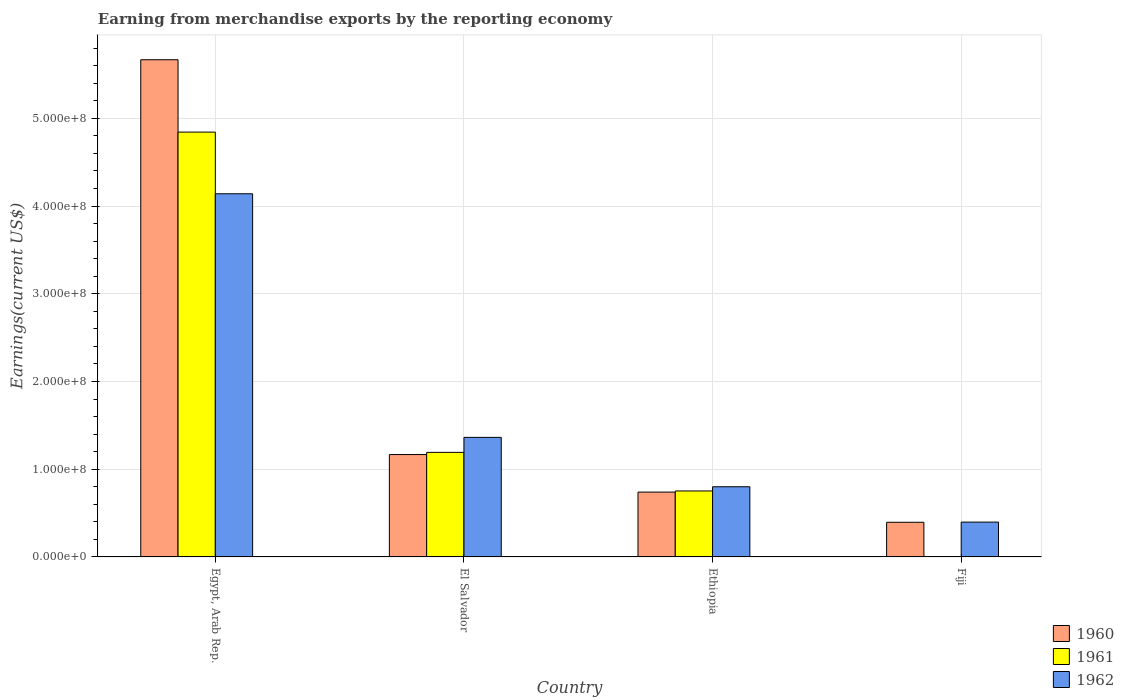Are the number of bars per tick equal to the number of legend labels?
Offer a very short reply. Yes. How many bars are there on the 1st tick from the left?
Provide a short and direct response. 3. How many bars are there on the 3rd tick from the right?
Make the answer very short. 3. What is the label of the 1st group of bars from the left?
Make the answer very short. Egypt, Arab Rep. In how many cases, is the number of bars for a given country not equal to the number of legend labels?
Make the answer very short. 0. What is the amount earned from merchandise exports in 1962 in Ethiopia?
Your answer should be very brief. 8.00e+07. Across all countries, what is the maximum amount earned from merchandise exports in 1961?
Offer a terse response. 4.84e+08. Across all countries, what is the minimum amount earned from merchandise exports in 1960?
Ensure brevity in your answer.  3.95e+07. In which country was the amount earned from merchandise exports in 1962 maximum?
Make the answer very short. Egypt, Arab Rep. In which country was the amount earned from merchandise exports in 1962 minimum?
Give a very brief answer. Fiji. What is the total amount earned from merchandise exports in 1961 in the graph?
Make the answer very short. 6.79e+08. What is the difference between the amount earned from merchandise exports in 1960 in Egypt, Arab Rep. and that in Ethiopia?
Your answer should be very brief. 4.93e+08. What is the difference between the amount earned from merchandise exports in 1960 in El Salvador and the amount earned from merchandise exports in 1962 in Ethiopia?
Provide a succinct answer. 3.67e+07. What is the average amount earned from merchandise exports in 1962 per country?
Provide a succinct answer. 1.68e+08. What is the difference between the amount earned from merchandise exports of/in 1960 and amount earned from merchandise exports of/in 1962 in Ethiopia?
Your answer should be very brief. -6.10e+06. In how many countries, is the amount earned from merchandise exports in 1962 greater than 560000000 US$?
Make the answer very short. 0. What is the ratio of the amount earned from merchandise exports in 1960 in Egypt, Arab Rep. to that in Ethiopia?
Ensure brevity in your answer.  7.67. What is the difference between the highest and the second highest amount earned from merchandise exports in 1960?
Provide a succinct answer. 4.50e+08. What is the difference between the highest and the lowest amount earned from merchandise exports in 1962?
Give a very brief answer. 3.74e+08. In how many countries, is the amount earned from merchandise exports in 1960 greater than the average amount earned from merchandise exports in 1960 taken over all countries?
Your answer should be very brief. 1. What does the 3rd bar from the left in Ethiopia represents?
Ensure brevity in your answer.  1962. How many bars are there?
Give a very brief answer. 12. How many countries are there in the graph?
Keep it short and to the point. 4. Does the graph contain any zero values?
Your answer should be compact. No. Does the graph contain grids?
Give a very brief answer. Yes. How are the legend labels stacked?
Offer a terse response. Vertical. What is the title of the graph?
Give a very brief answer. Earning from merchandise exports by the reporting economy. Does "1984" appear as one of the legend labels in the graph?
Offer a terse response. No. What is the label or title of the X-axis?
Give a very brief answer. Country. What is the label or title of the Y-axis?
Give a very brief answer. Earnings(current US$). What is the Earnings(current US$) in 1960 in Egypt, Arab Rep.?
Ensure brevity in your answer.  5.67e+08. What is the Earnings(current US$) in 1961 in Egypt, Arab Rep.?
Offer a very short reply. 4.84e+08. What is the Earnings(current US$) in 1962 in Egypt, Arab Rep.?
Make the answer very short. 4.14e+08. What is the Earnings(current US$) of 1960 in El Salvador?
Offer a very short reply. 1.17e+08. What is the Earnings(current US$) in 1961 in El Salvador?
Your answer should be compact. 1.19e+08. What is the Earnings(current US$) of 1962 in El Salvador?
Provide a short and direct response. 1.36e+08. What is the Earnings(current US$) in 1960 in Ethiopia?
Your answer should be compact. 7.39e+07. What is the Earnings(current US$) in 1961 in Ethiopia?
Your answer should be very brief. 7.52e+07. What is the Earnings(current US$) of 1962 in Ethiopia?
Your answer should be very brief. 8.00e+07. What is the Earnings(current US$) of 1960 in Fiji?
Provide a short and direct response. 3.95e+07. What is the Earnings(current US$) in 1962 in Fiji?
Keep it short and to the point. 3.97e+07. Across all countries, what is the maximum Earnings(current US$) of 1960?
Provide a succinct answer. 5.67e+08. Across all countries, what is the maximum Earnings(current US$) in 1961?
Provide a short and direct response. 4.84e+08. Across all countries, what is the maximum Earnings(current US$) in 1962?
Your answer should be compact. 4.14e+08. Across all countries, what is the minimum Earnings(current US$) of 1960?
Keep it short and to the point. 3.95e+07. Across all countries, what is the minimum Earnings(current US$) of 1962?
Offer a very short reply. 3.97e+07. What is the total Earnings(current US$) in 1960 in the graph?
Provide a succinct answer. 7.97e+08. What is the total Earnings(current US$) in 1961 in the graph?
Offer a terse response. 6.79e+08. What is the total Earnings(current US$) of 1962 in the graph?
Offer a terse response. 6.70e+08. What is the difference between the Earnings(current US$) in 1960 in Egypt, Arab Rep. and that in El Salvador?
Give a very brief answer. 4.50e+08. What is the difference between the Earnings(current US$) of 1961 in Egypt, Arab Rep. and that in El Salvador?
Offer a terse response. 3.65e+08. What is the difference between the Earnings(current US$) in 1962 in Egypt, Arab Rep. and that in El Salvador?
Ensure brevity in your answer.  2.78e+08. What is the difference between the Earnings(current US$) in 1960 in Egypt, Arab Rep. and that in Ethiopia?
Your response must be concise. 4.93e+08. What is the difference between the Earnings(current US$) in 1961 in Egypt, Arab Rep. and that in Ethiopia?
Your answer should be very brief. 4.09e+08. What is the difference between the Earnings(current US$) in 1962 in Egypt, Arab Rep. and that in Ethiopia?
Provide a succinct answer. 3.34e+08. What is the difference between the Earnings(current US$) of 1960 in Egypt, Arab Rep. and that in Fiji?
Make the answer very short. 5.27e+08. What is the difference between the Earnings(current US$) in 1961 in Egypt, Arab Rep. and that in Fiji?
Your answer should be compact. 4.84e+08. What is the difference between the Earnings(current US$) in 1962 in Egypt, Arab Rep. and that in Fiji?
Ensure brevity in your answer.  3.74e+08. What is the difference between the Earnings(current US$) in 1960 in El Salvador and that in Ethiopia?
Your response must be concise. 4.28e+07. What is the difference between the Earnings(current US$) of 1961 in El Salvador and that in Ethiopia?
Keep it short and to the point. 4.40e+07. What is the difference between the Earnings(current US$) in 1962 in El Salvador and that in Ethiopia?
Offer a terse response. 5.63e+07. What is the difference between the Earnings(current US$) in 1960 in El Salvador and that in Fiji?
Your answer should be very brief. 7.72e+07. What is the difference between the Earnings(current US$) in 1961 in El Salvador and that in Fiji?
Ensure brevity in your answer.  1.19e+08. What is the difference between the Earnings(current US$) of 1962 in El Salvador and that in Fiji?
Provide a short and direct response. 9.66e+07. What is the difference between the Earnings(current US$) of 1960 in Ethiopia and that in Fiji?
Make the answer very short. 3.44e+07. What is the difference between the Earnings(current US$) of 1961 in Ethiopia and that in Fiji?
Your answer should be very brief. 7.50e+07. What is the difference between the Earnings(current US$) of 1962 in Ethiopia and that in Fiji?
Give a very brief answer. 4.03e+07. What is the difference between the Earnings(current US$) of 1960 in Egypt, Arab Rep. and the Earnings(current US$) of 1961 in El Salvador?
Provide a succinct answer. 4.48e+08. What is the difference between the Earnings(current US$) in 1960 in Egypt, Arab Rep. and the Earnings(current US$) in 1962 in El Salvador?
Provide a short and direct response. 4.30e+08. What is the difference between the Earnings(current US$) of 1961 in Egypt, Arab Rep. and the Earnings(current US$) of 1962 in El Salvador?
Your answer should be very brief. 3.48e+08. What is the difference between the Earnings(current US$) in 1960 in Egypt, Arab Rep. and the Earnings(current US$) in 1961 in Ethiopia?
Provide a succinct answer. 4.92e+08. What is the difference between the Earnings(current US$) of 1960 in Egypt, Arab Rep. and the Earnings(current US$) of 1962 in Ethiopia?
Your answer should be very brief. 4.87e+08. What is the difference between the Earnings(current US$) of 1961 in Egypt, Arab Rep. and the Earnings(current US$) of 1962 in Ethiopia?
Your answer should be very brief. 4.04e+08. What is the difference between the Earnings(current US$) in 1960 in Egypt, Arab Rep. and the Earnings(current US$) in 1961 in Fiji?
Provide a short and direct response. 5.67e+08. What is the difference between the Earnings(current US$) of 1960 in Egypt, Arab Rep. and the Earnings(current US$) of 1962 in Fiji?
Make the answer very short. 5.27e+08. What is the difference between the Earnings(current US$) of 1961 in Egypt, Arab Rep. and the Earnings(current US$) of 1962 in Fiji?
Provide a short and direct response. 4.45e+08. What is the difference between the Earnings(current US$) in 1960 in El Salvador and the Earnings(current US$) in 1961 in Ethiopia?
Give a very brief answer. 4.15e+07. What is the difference between the Earnings(current US$) of 1960 in El Salvador and the Earnings(current US$) of 1962 in Ethiopia?
Your answer should be very brief. 3.67e+07. What is the difference between the Earnings(current US$) of 1961 in El Salvador and the Earnings(current US$) of 1962 in Ethiopia?
Ensure brevity in your answer.  3.92e+07. What is the difference between the Earnings(current US$) of 1960 in El Salvador and the Earnings(current US$) of 1961 in Fiji?
Make the answer very short. 1.16e+08. What is the difference between the Earnings(current US$) of 1960 in El Salvador and the Earnings(current US$) of 1962 in Fiji?
Provide a short and direct response. 7.70e+07. What is the difference between the Earnings(current US$) of 1961 in El Salvador and the Earnings(current US$) of 1962 in Fiji?
Your response must be concise. 7.95e+07. What is the difference between the Earnings(current US$) in 1960 in Ethiopia and the Earnings(current US$) in 1961 in Fiji?
Your answer should be very brief. 7.37e+07. What is the difference between the Earnings(current US$) of 1960 in Ethiopia and the Earnings(current US$) of 1962 in Fiji?
Your answer should be compact. 3.42e+07. What is the difference between the Earnings(current US$) in 1961 in Ethiopia and the Earnings(current US$) in 1962 in Fiji?
Your response must be concise. 3.55e+07. What is the average Earnings(current US$) of 1960 per country?
Your answer should be compact. 1.99e+08. What is the average Earnings(current US$) of 1961 per country?
Your response must be concise. 1.70e+08. What is the average Earnings(current US$) of 1962 per country?
Offer a terse response. 1.68e+08. What is the difference between the Earnings(current US$) of 1960 and Earnings(current US$) of 1961 in Egypt, Arab Rep.?
Your response must be concise. 8.25e+07. What is the difference between the Earnings(current US$) of 1960 and Earnings(current US$) of 1962 in Egypt, Arab Rep.?
Make the answer very short. 1.53e+08. What is the difference between the Earnings(current US$) of 1961 and Earnings(current US$) of 1962 in Egypt, Arab Rep.?
Give a very brief answer. 7.03e+07. What is the difference between the Earnings(current US$) of 1960 and Earnings(current US$) of 1961 in El Salvador?
Offer a very short reply. -2.50e+06. What is the difference between the Earnings(current US$) in 1960 and Earnings(current US$) in 1962 in El Salvador?
Provide a succinct answer. -1.96e+07. What is the difference between the Earnings(current US$) in 1961 and Earnings(current US$) in 1962 in El Salvador?
Give a very brief answer. -1.71e+07. What is the difference between the Earnings(current US$) of 1960 and Earnings(current US$) of 1961 in Ethiopia?
Provide a short and direct response. -1.30e+06. What is the difference between the Earnings(current US$) of 1960 and Earnings(current US$) of 1962 in Ethiopia?
Provide a succinct answer. -6.10e+06. What is the difference between the Earnings(current US$) of 1961 and Earnings(current US$) of 1962 in Ethiopia?
Your response must be concise. -4.80e+06. What is the difference between the Earnings(current US$) of 1960 and Earnings(current US$) of 1961 in Fiji?
Provide a succinct answer. 3.93e+07. What is the difference between the Earnings(current US$) of 1961 and Earnings(current US$) of 1962 in Fiji?
Offer a terse response. -3.95e+07. What is the ratio of the Earnings(current US$) in 1960 in Egypt, Arab Rep. to that in El Salvador?
Keep it short and to the point. 4.86. What is the ratio of the Earnings(current US$) of 1961 in Egypt, Arab Rep. to that in El Salvador?
Give a very brief answer. 4.06. What is the ratio of the Earnings(current US$) in 1962 in Egypt, Arab Rep. to that in El Salvador?
Provide a succinct answer. 3.04. What is the ratio of the Earnings(current US$) in 1960 in Egypt, Arab Rep. to that in Ethiopia?
Offer a very short reply. 7.67. What is the ratio of the Earnings(current US$) in 1961 in Egypt, Arab Rep. to that in Ethiopia?
Your answer should be compact. 6.44. What is the ratio of the Earnings(current US$) of 1962 in Egypt, Arab Rep. to that in Ethiopia?
Ensure brevity in your answer.  5.17. What is the ratio of the Earnings(current US$) in 1960 in Egypt, Arab Rep. to that in Fiji?
Your response must be concise. 14.35. What is the ratio of the Earnings(current US$) in 1961 in Egypt, Arab Rep. to that in Fiji?
Make the answer very short. 2421.5. What is the ratio of the Earnings(current US$) of 1962 in Egypt, Arab Rep. to that in Fiji?
Your response must be concise. 10.43. What is the ratio of the Earnings(current US$) in 1960 in El Salvador to that in Ethiopia?
Make the answer very short. 1.58. What is the ratio of the Earnings(current US$) in 1961 in El Salvador to that in Ethiopia?
Your answer should be compact. 1.59. What is the ratio of the Earnings(current US$) of 1962 in El Salvador to that in Ethiopia?
Your response must be concise. 1.7. What is the ratio of the Earnings(current US$) of 1960 in El Salvador to that in Fiji?
Offer a terse response. 2.95. What is the ratio of the Earnings(current US$) of 1961 in El Salvador to that in Fiji?
Keep it short and to the point. 596. What is the ratio of the Earnings(current US$) of 1962 in El Salvador to that in Fiji?
Provide a succinct answer. 3.43. What is the ratio of the Earnings(current US$) in 1960 in Ethiopia to that in Fiji?
Your answer should be very brief. 1.87. What is the ratio of the Earnings(current US$) in 1961 in Ethiopia to that in Fiji?
Your response must be concise. 376. What is the ratio of the Earnings(current US$) of 1962 in Ethiopia to that in Fiji?
Your response must be concise. 2.02. What is the difference between the highest and the second highest Earnings(current US$) in 1960?
Your answer should be compact. 4.50e+08. What is the difference between the highest and the second highest Earnings(current US$) of 1961?
Make the answer very short. 3.65e+08. What is the difference between the highest and the second highest Earnings(current US$) in 1962?
Offer a very short reply. 2.78e+08. What is the difference between the highest and the lowest Earnings(current US$) of 1960?
Your answer should be compact. 5.27e+08. What is the difference between the highest and the lowest Earnings(current US$) of 1961?
Ensure brevity in your answer.  4.84e+08. What is the difference between the highest and the lowest Earnings(current US$) of 1962?
Make the answer very short. 3.74e+08. 